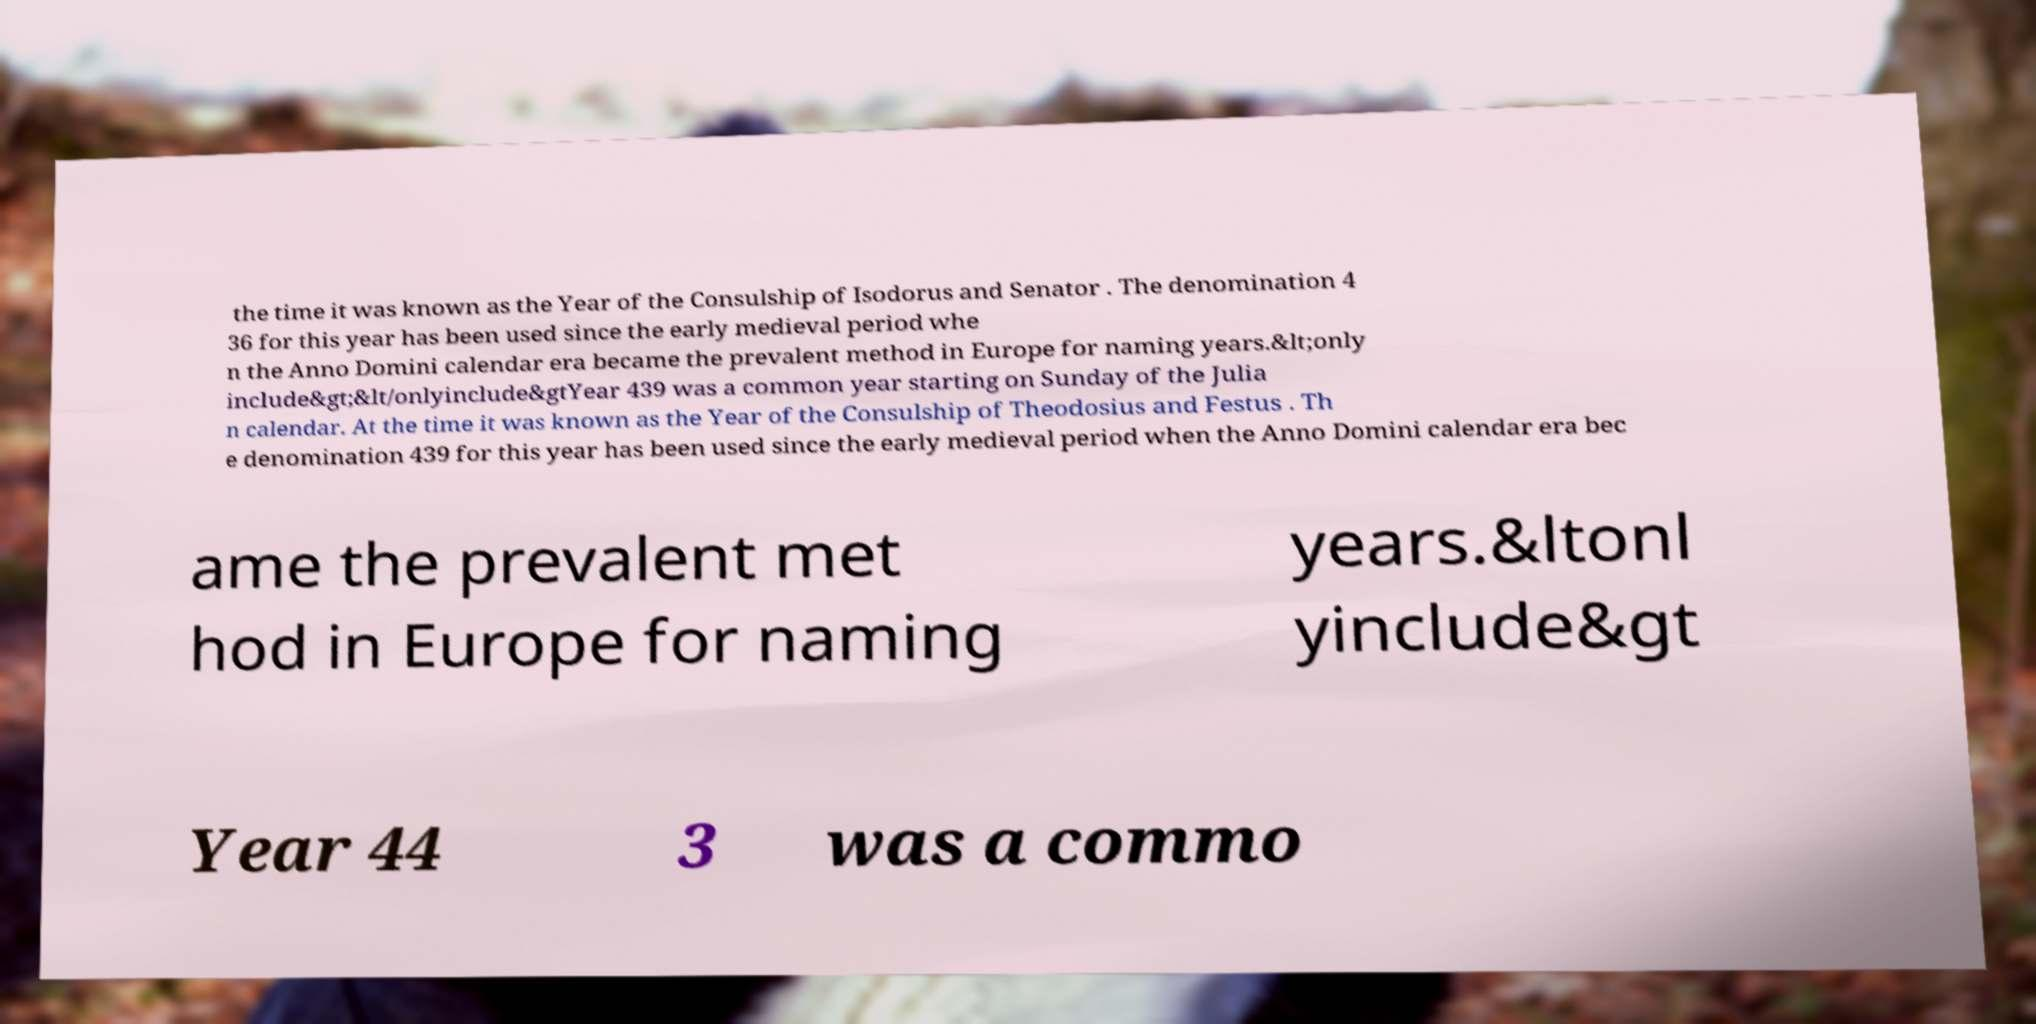There's text embedded in this image that I need extracted. Can you transcribe it verbatim? the time it was known as the Year of the Consulship of Isodorus and Senator . The denomination 4 36 for this year has been used since the early medieval period whe n the Anno Domini calendar era became the prevalent method in Europe for naming years.&lt;only include&gt;&lt/onlyinclude&gtYear 439 was a common year starting on Sunday of the Julia n calendar. At the time it was known as the Year of the Consulship of Theodosius and Festus . Th e denomination 439 for this year has been used since the early medieval period when the Anno Domini calendar era bec ame the prevalent met hod in Europe for naming years.&ltonl yinclude&gt Year 44 3 was a commo 